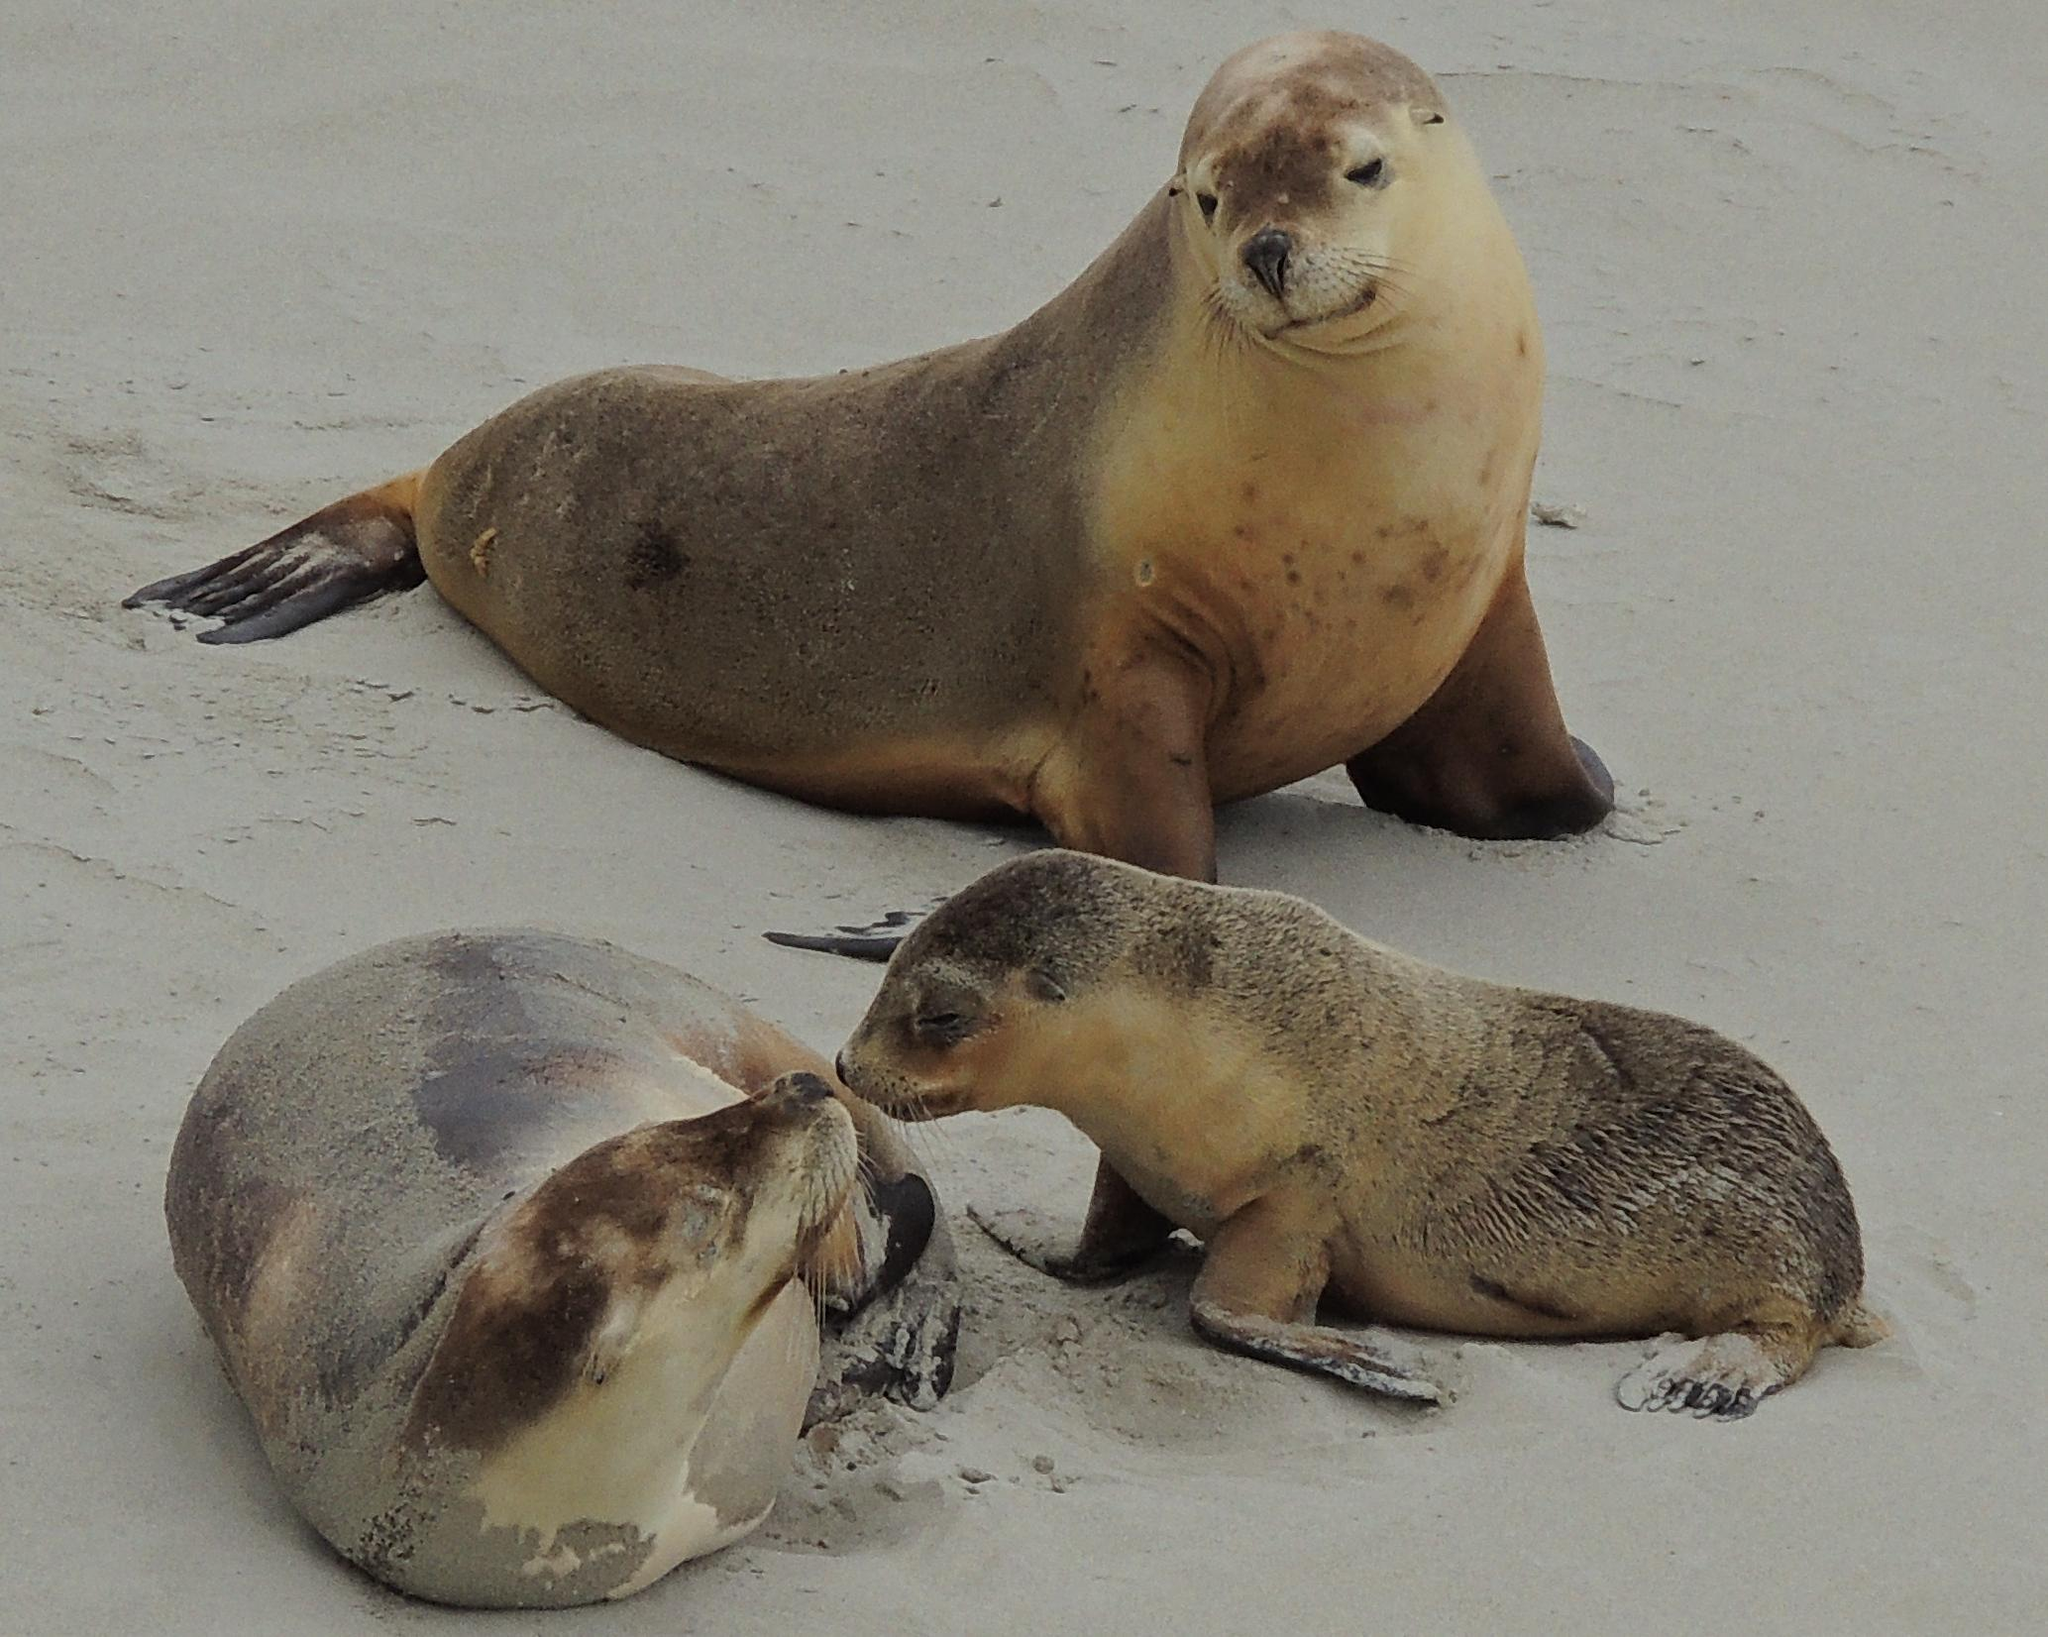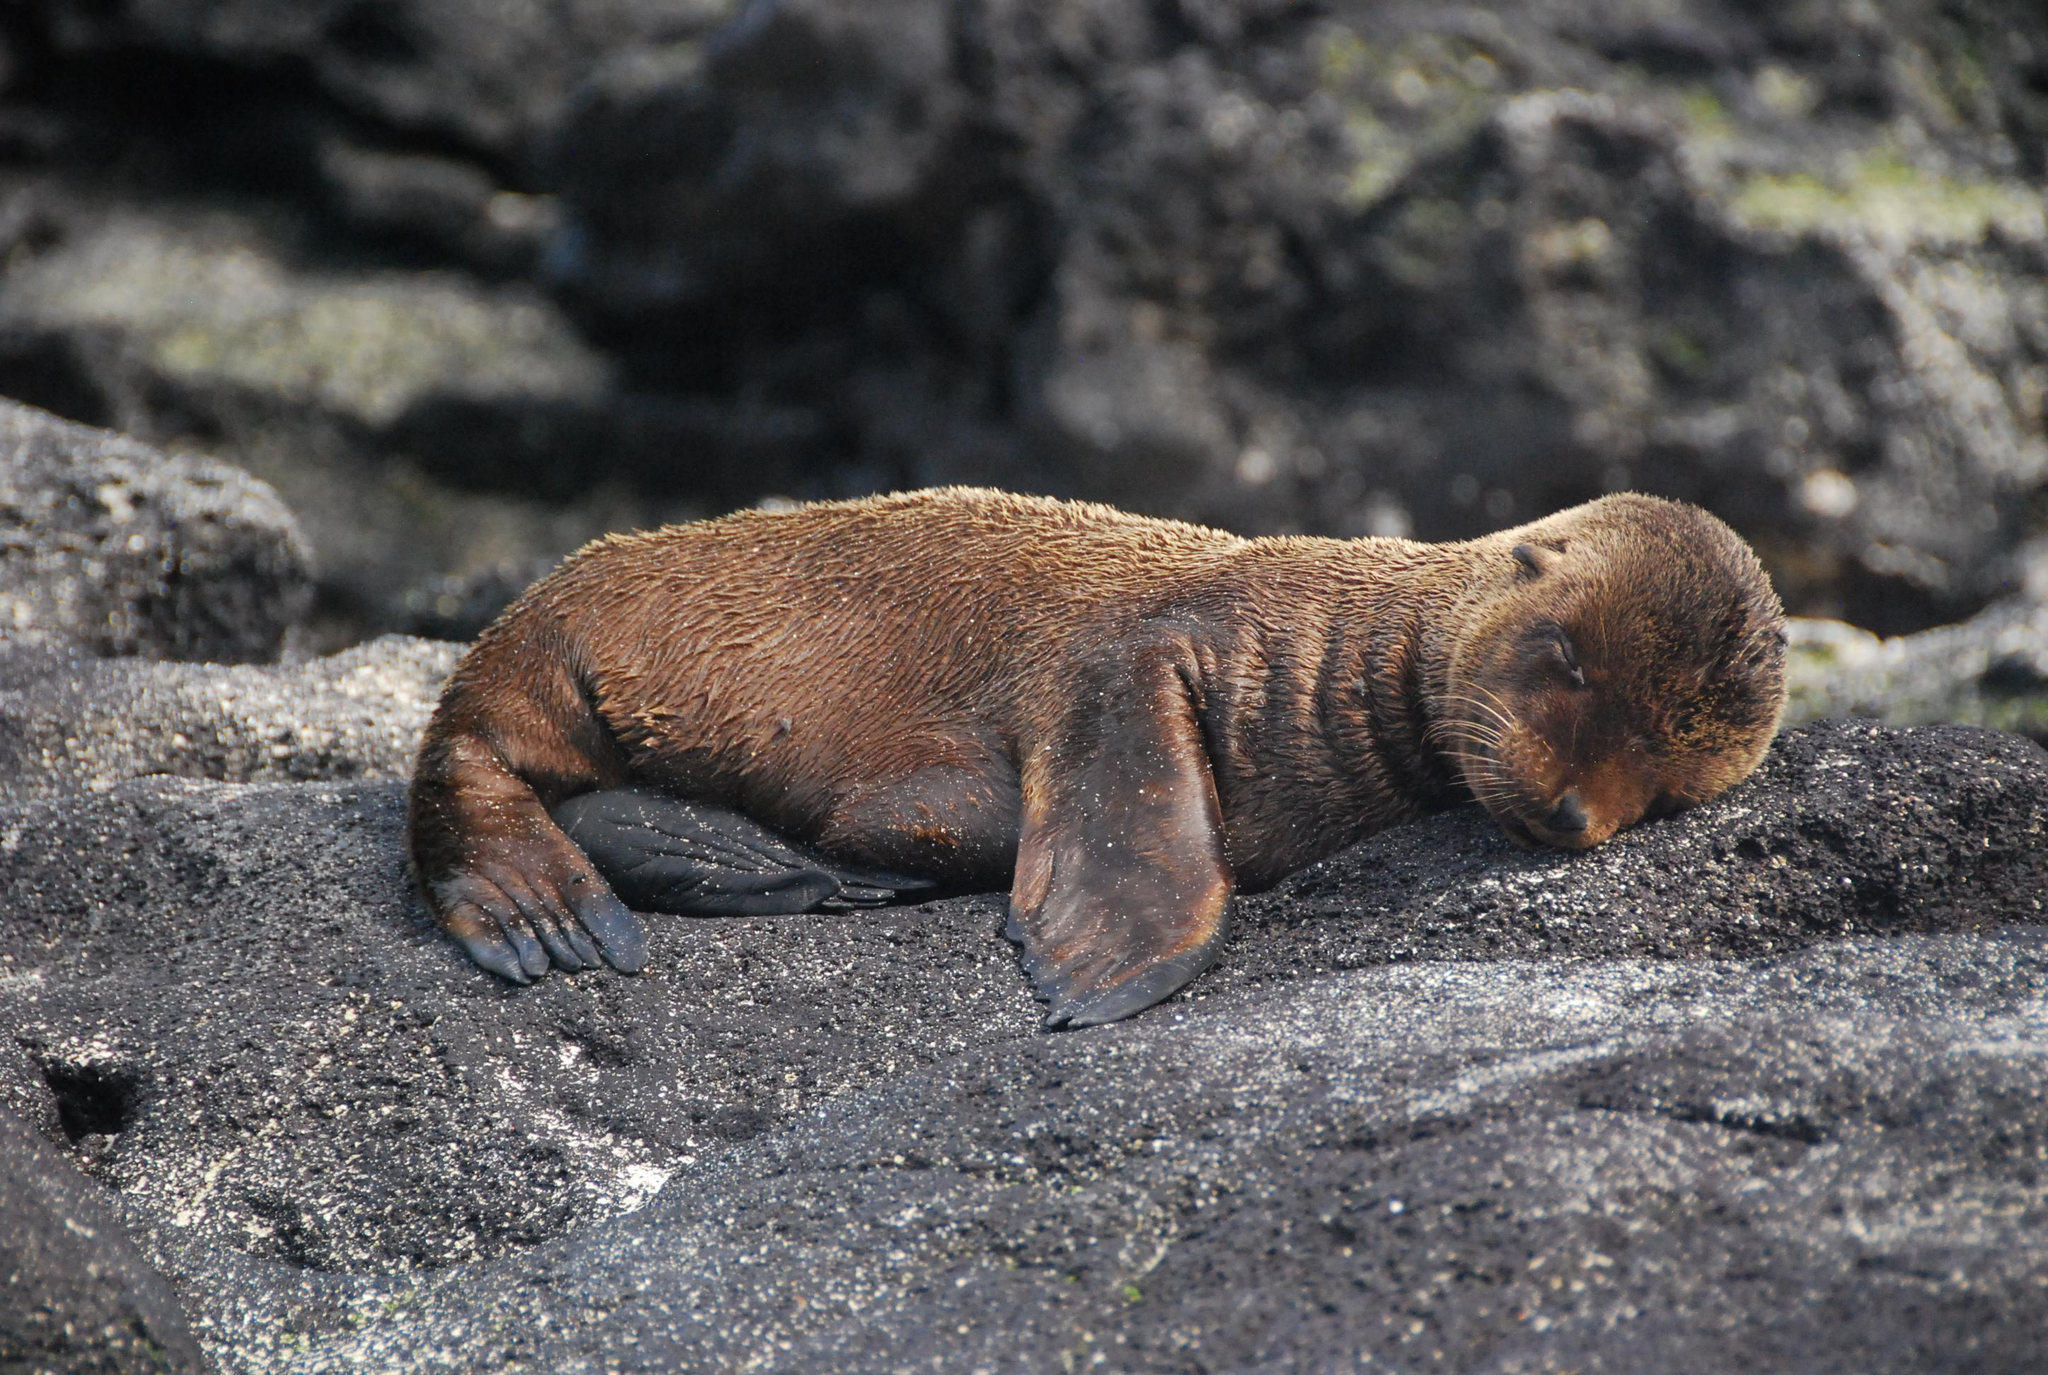The first image is the image on the left, the second image is the image on the right. Given the left and right images, does the statement "The right image contains an adult seal with a child seal." hold true? Answer yes or no. No. The first image is the image on the left, the second image is the image on the right. Analyze the images presented: Is the assertion "An image shows an adult seal on the right with its neck turned to point its nose down toward a baby seal." valid? Answer yes or no. No. 